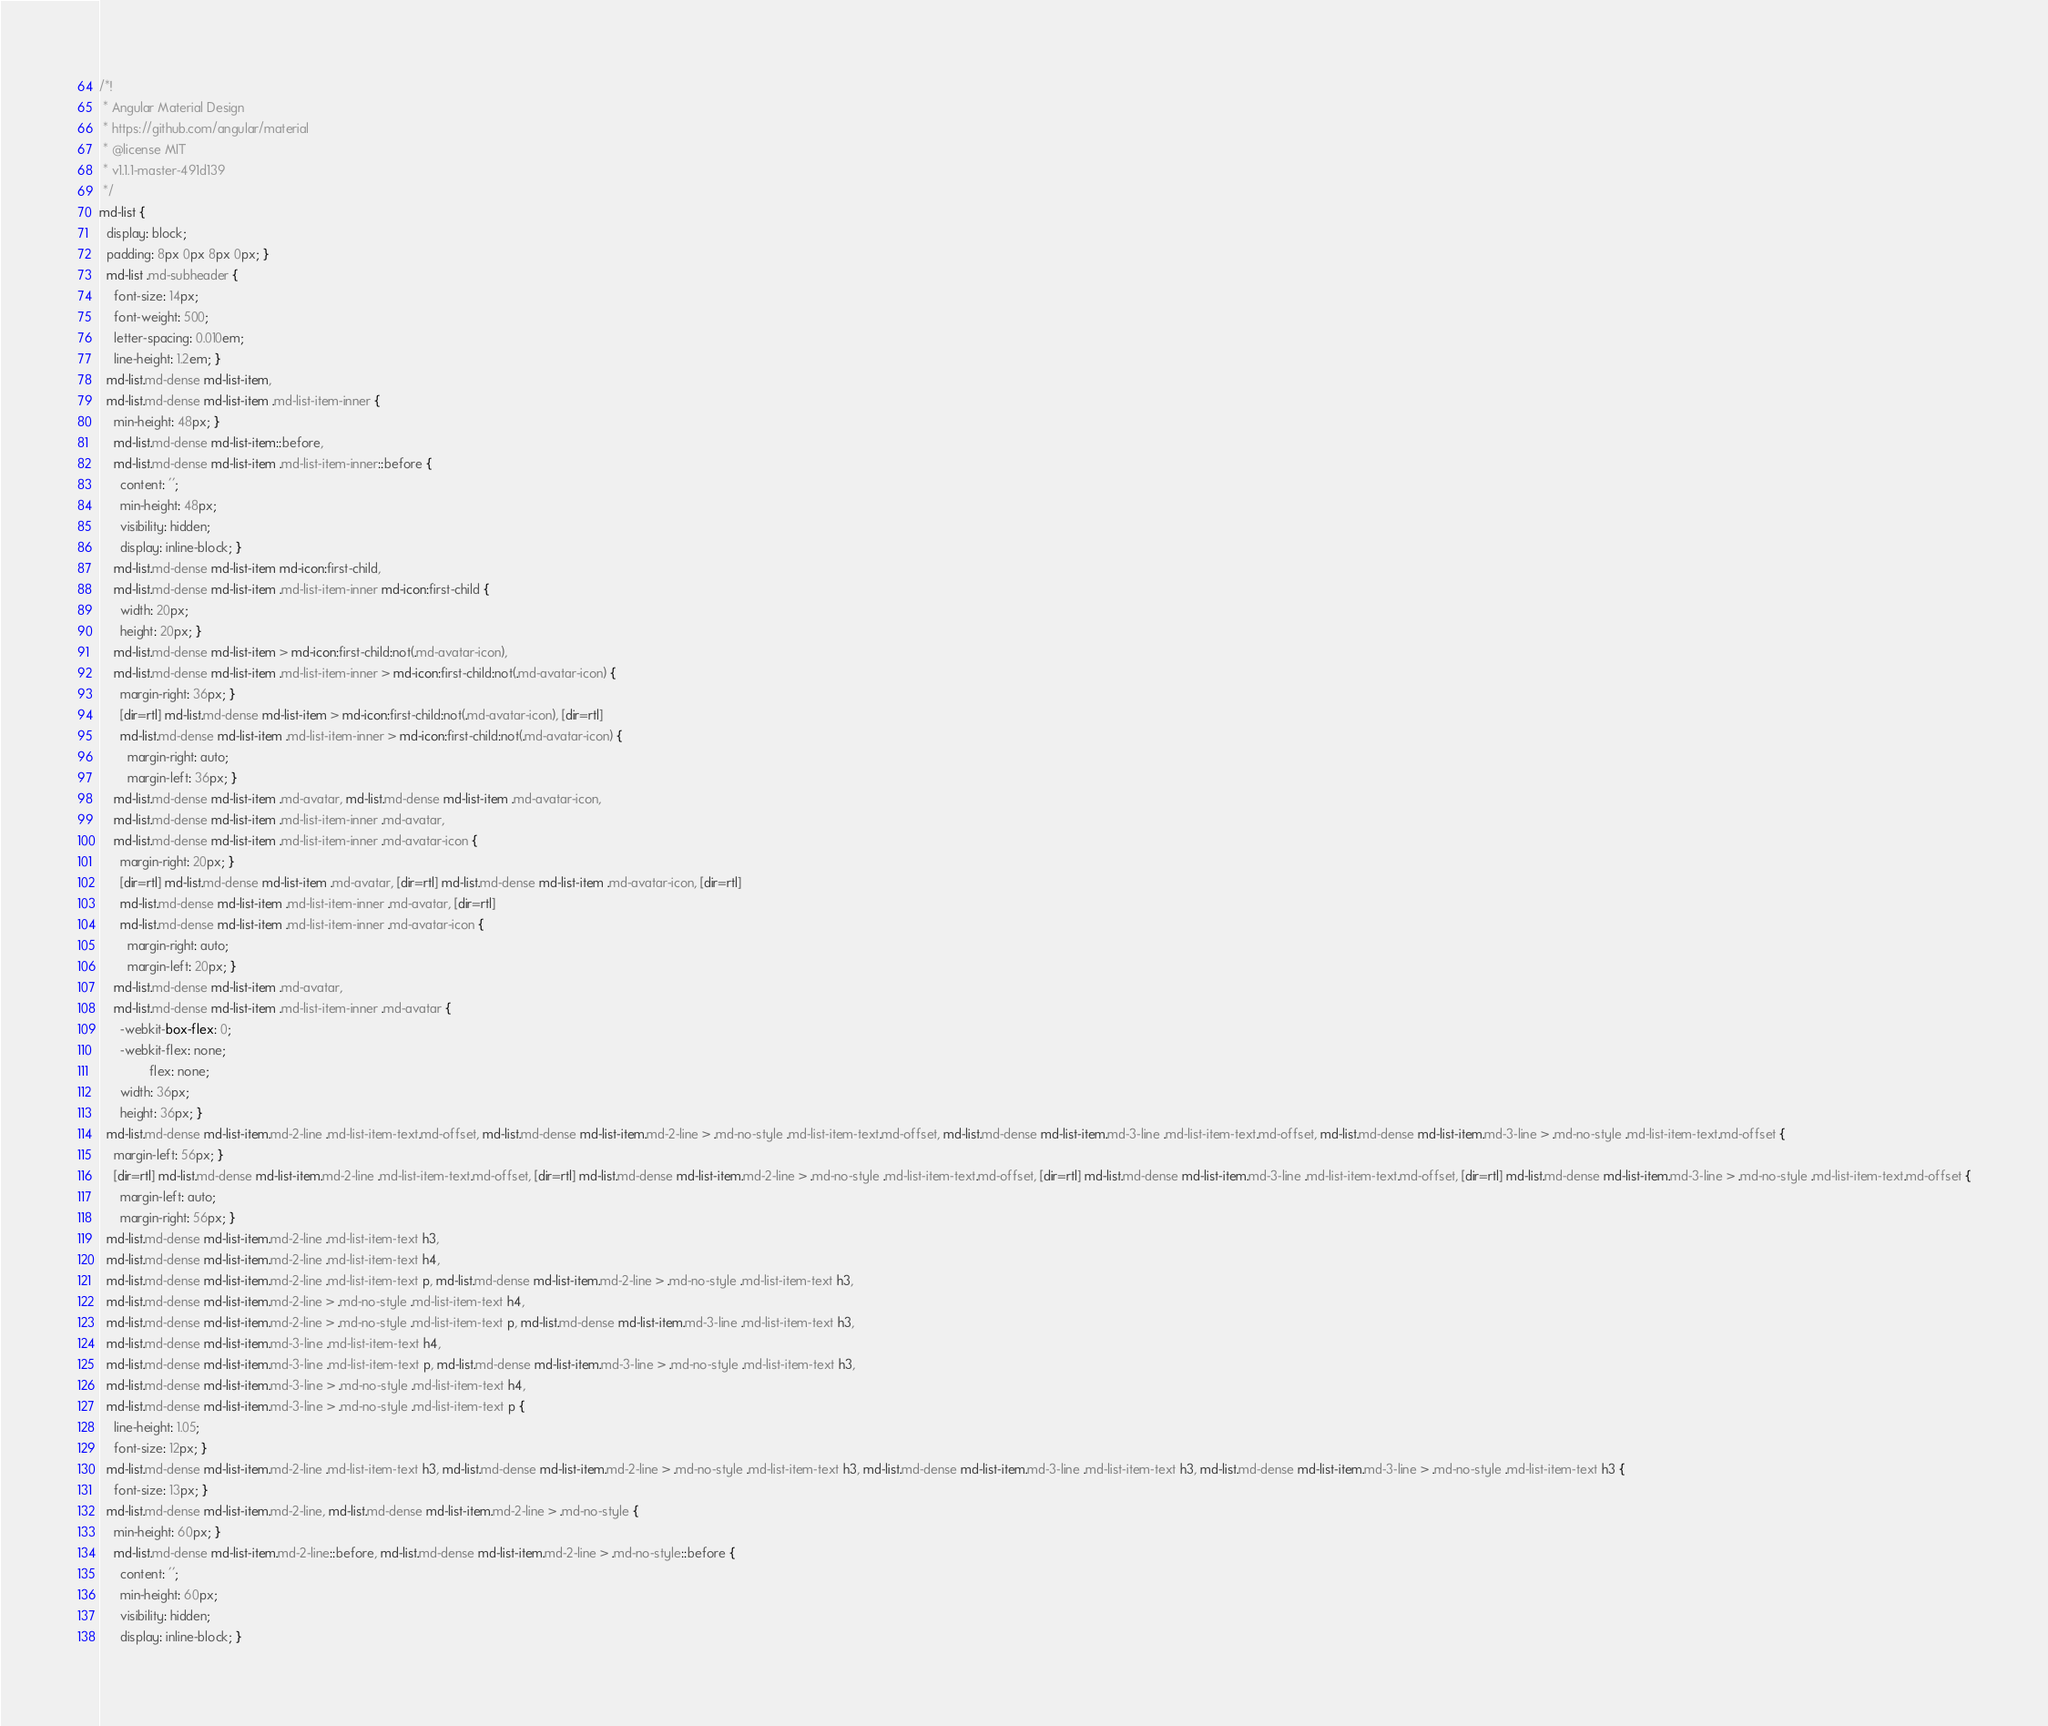<code> <loc_0><loc_0><loc_500><loc_500><_CSS_>/*!
 * Angular Material Design
 * https://github.com/angular/material
 * @license MIT
 * v1.1.1-master-491d139
 */
md-list {
  display: block;
  padding: 8px 0px 8px 0px; }
  md-list .md-subheader {
    font-size: 14px;
    font-weight: 500;
    letter-spacing: 0.010em;
    line-height: 1.2em; }
  md-list.md-dense md-list-item,
  md-list.md-dense md-list-item .md-list-item-inner {
    min-height: 48px; }
    md-list.md-dense md-list-item::before,
    md-list.md-dense md-list-item .md-list-item-inner::before {
      content: '';
      min-height: 48px;
      visibility: hidden;
      display: inline-block; }
    md-list.md-dense md-list-item md-icon:first-child,
    md-list.md-dense md-list-item .md-list-item-inner md-icon:first-child {
      width: 20px;
      height: 20px; }
    md-list.md-dense md-list-item > md-icon:first-child:not(.md-avatar-icon),
    md-list.md-dense md-list-item .md-list-item-inner > md-icon:first-child:not(.md-avatar-icon) {
      margin-right: 36px; }
      [dir=rtl] md-list.md-dense md-list-item > md-icon:first-child:not(.md-avatar-icon), [dir=rtl]
      md-list.md-dense md-list-item .md-list-item-inner > md-icon:first-child:not(.md-avatar-icon) {
        margin-right: auto;
        margin-left: 36px; }
    md-list.md-dense md-list-item .md-avatar, md-list.md-dense md-list-item .md-avatar-icon,
    md-list.md-dense md-list-item .md-list-item-inner .md-avatar,
    md-list.md-dense md-list-item .md-list-item-inner .md-avatar-icon {
      margin-right: 20px; }
      [dir=rtl] md-list.md-dense md-list-item .md-avatar, [dir=rtl] md-list.md-dense md-list-item .md-avatar-icon, [dir=rtl]
      md-list.md-dense md-list-item .md-list-item-inner .md-avatar, [dir=rtl]
      md-list.md-dense md-list-item .md-list-item-inner .md-avatar-icon {
        margin-right: auto;
        margin-left: 20px; }
    md-list.md-dense md-list-item .md-avatar,
    md-list.md-dense md-list-item .md-list-item-inner .md-avatar {
      -webkit-box-flex: 0;
      -webkit-flex: none;
              flex: none;
      width: 36px;
      height: 36px; }
  md-list.md-dense md-list-item.md-2-line .md-list-item-text.md-offset, md-list.md-dense md-list-item.md-2-line > .md-no-style .md-list-item-text.md-offset, md-list.md-dense md-list-item.md-3-line .md-list-item-text.md-offset, md-list.md-dense md-list-item.md-3-line > .md-no-style .md-list-item-text.md-offset {
    margin-left: 56px; }
    [dir=rtl] md-list.md-dense md-list-item.md-2-line .md-list-item-text.md-offset, [dir=rtl] md-list.md-dense md-list-item.md-2-line > .md-no-style .md-list-item-text.md-offset, [dir=rtl] md-list.md-dense md-list-item.md-3-line .md-list-item-text.md-offset, [dir=rtl] md-list.md-dense md-list-item.md-3-line > .md-no-style .md-list-item-text.md-offset {
      margin-left: auto;
      margin-right: 56px; }
  md-list.md-dense md-list-item.md-2-line .md-list-item-text h3,
  md-list.md-dense md-list-item.md-2-line .md-list-item-text h4,
  md-list.md-dense md-list-item.md-2-line .md-list-item-text p, md-list.md-dense md-list-item.md-2-line > .md-no-style .md-list-item-text h3,
  md-list.md-dense md-list-item.md-2-line > .md-no-style .md-list-item-text h4,
  md-list.md-dense md-list-item.md-2-line > .md-no-style .md-list-item-text p, md-list.md-dense md-list-item.md-3-line .md-list-item-text h3,
  md-list.md-dense md-list-item.md-3-line .md-list-item-text h4,
  md-list.md-dense md-list-item.md-3-line .md-list-item-text p, md-list.md-dense md-list-item.md-3-line > .md-no-style .md-list-item-text h3,
  md-list.md-dense md-list-item.md-3-line > .md-no-style .md-list-item-text h4,
  md-list.md-dense md-list-item.md-3-line > .md-no-style .md-list-item-text p {
    line-height: 1.05;
    font-size: 12px; }
  md-list.md-dense md-list-item.md-2-line .md-list-item-text h3, md-list.md-dense md-list-item.md-2-line > .md-no-style .md-list-item-text h3, md-list.md-dense md-list-item.md-3-line .md-list-item-text h3, md-list.md-dense md-list-item.md-3-line > .md-no-style .md-list-item-text h3 {
    font-size: 13px; }
  md-list.md-dense md-list-item.md-2-line, md-list.md-dense md-list-item.md-2-line > .md-no-style {
    min-height: 60px; }
    md-list.md-dense md-list-item.md-2-line::before, md-list.md-dense md-list-item.md-2-line > .md-no-style::before {
      content: '';
      min-height: 60px;
      visibility: hidden;
      display: inline-block; }</code> 